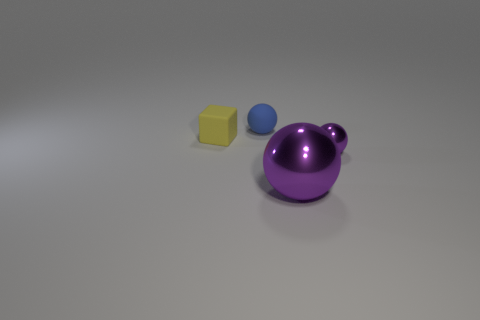Can you tell me what materials these objects might be made of based on their appearance? The objects appear to have a smooth, reflective surface, suggesting they could be made of a polished, possibly synthetic material, like plastic. The big purple object, due to its glossiness, might even resemble a ceramic or glass material. 